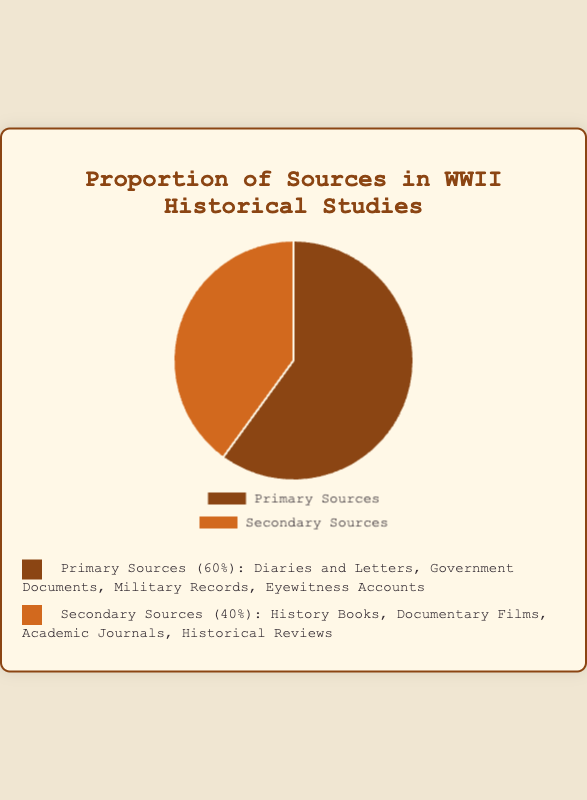What percentage of sources used in WWII historical studies are primary sources? The pie chart shows that primary sources make up 60% of the total sources used. This is directly visible from the chart segment labeled "Primary Sources" and also mentioned in the legend.
Answer: 60% What percentage of sources used in WWII historical studies are secondary sources? The pie chart indicates that secondary sources account for 40% of the total sources used. This is directly visible from the chart segment labeled "Secondary Sources" and also mentioned in the legend.
Answer: 40% How much larger is the proportion of primary sources compared to secondary sources? The pie chart shows that primary sources are 60% and secondary sources are 40%. The difference in their proportions is 60% - 40%.
Answer: 20% If you combine both primary and secondary sources, what is the total percentage? Since the pie chart represents the whole data set, the total percentage of primary and secondary sources combined is 100%. This is because all segments of a pie chart must add up to 100%.
Answer: 100% Which type of source has a higher proportion, and by what amount? The pie chart indicates that primary sources have a higher proportion at 60%, compared to secondary sources at 40%. The difference between them is 60% - 40%.
Answer: Primary Sources by 20% Based on the color coding, what color represents primary sources? The legend shows that primary sources are represented by the color brown. This color is associated with the 60% section of the pie chart.
Answer: Brown Based on the color coding, what color represents secondary sources? The legend indicates that secondary sources are represented by the color orange. This color corresponds to the 40% section of the pie chart.
Answer: Orange What is the average percentage of primary and secondary sources combined? The pie chart shows that primary sources are 60% and secondary sources are 40%. The average is calculated by (60% + 40%) / 2.
Answer: 50% By looking at the pie chart, what example can be categorized under primary sources? The pie chart legend lists examples under "Primary Sources." One such example is "Diaries and Letters."
Answer: Diaries and Letters How does the proportion of primary sources compare to secondary sources visually? The pie chart visually shows that the segment for primary sources is larger than that for secondary sources. Specifically, the primary source segment covers 60% of the circle, while the secondary source segment covers 40%, which makes the primary source section significantly larger.
Answer: Larger 